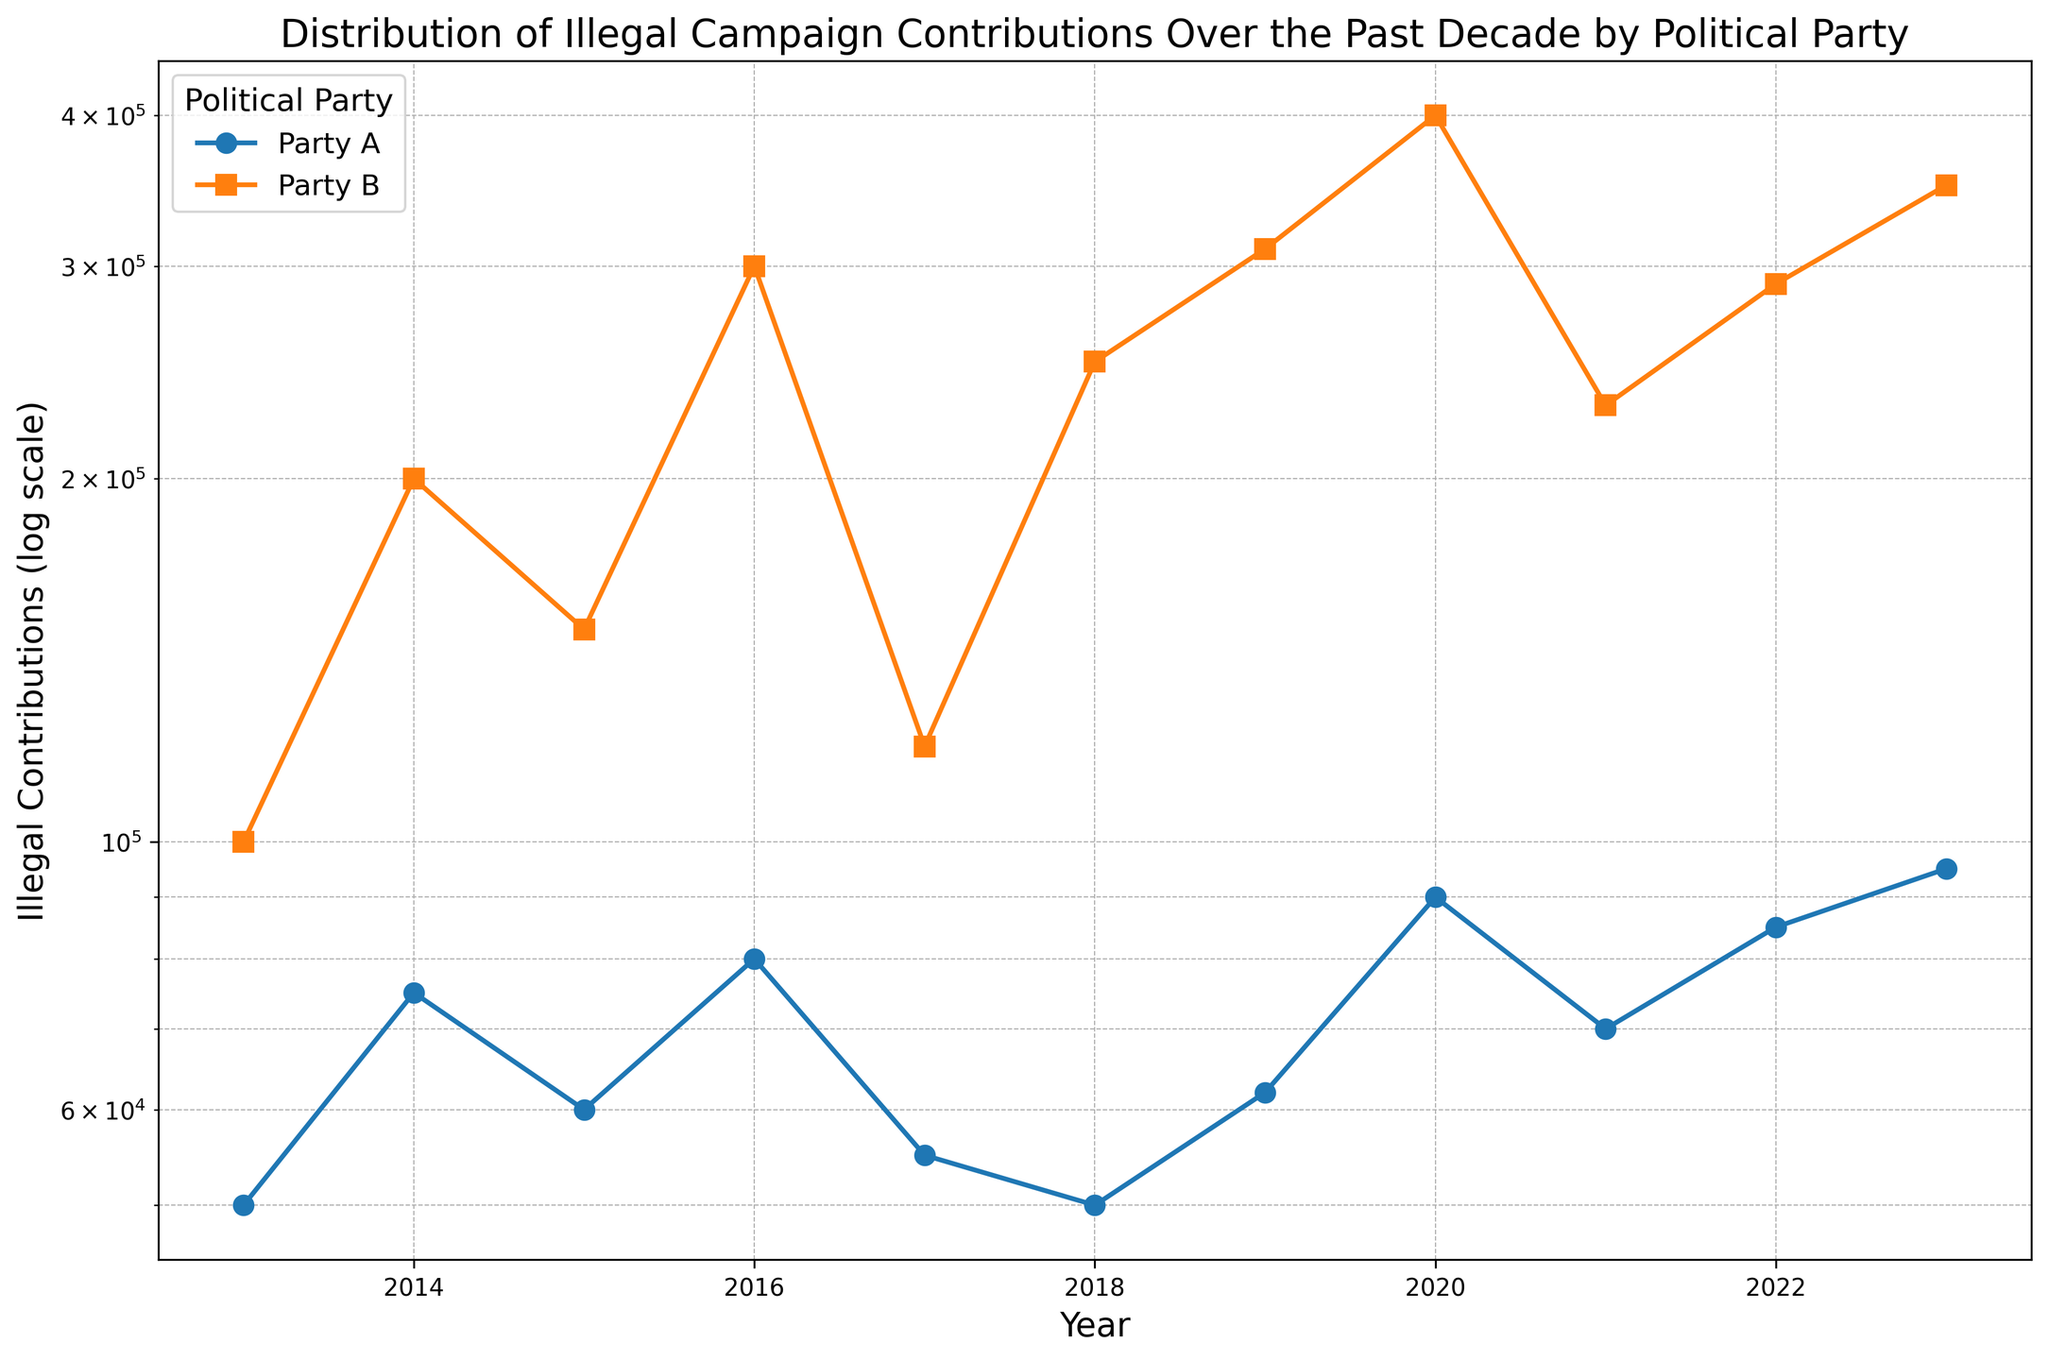Which party received the highest illegal contributions overall? To find the party with the highest illegal contributions overall, compare the contributions for each party over each year. Party B consistently has higher contributions than Party A in every year.
Answer: Party B During which year did Party A receive the most illegal contributions? Look at the data points for Party A across all years. The highest point for Party A occurs in 2023 with 95,000 illegal contributions.
Answer: 2023 Compare the illegal contributions of Party A and Party B in 2020. Which party received more, and by how much? In 2020, Party A received 90,000 illegal contributions, while Party B received 400,000. The difference is 400,000 - 90,000 = 310,000. Party B received 310,000 more illegal contributions.
Answer: Party B, 310,000 What is the overall trend in illegal contributions for Party A over the decade? Observe the line trend for Party A. It fluctuates yearly but generally shows a slight increasing trend from 50,000 in 2013 to 95,000 in 2023.
Answer: Increasing trend How many times did Party B receive illegal contributions greater than 300,000 in a year? Check yearly contributions for Party B. The amounts greater than 300,000 occur in 2019, 2020, and 2023, making it three times.
Answer: Three times In what year did Party B see the largest increase in illegal contributions compared to the previous year? Calculate the year-on-year difference for Party B. The largest increase is from 2015 (150,000) to 2016 (300,000), which is an increase of 150,000.
Answer: 2016 On average, which party had higher illegal contributions over the decade? Sum the contributions for each party over the years and divide by the number of years (10). Party A's total is 705,000, averaging 70,500/year. Party B's total is 2,700,000, averaging 270,000/year.
Answer: Party B During which years did Party B receive illegal contributions less than 150,000? Identify the years where Party B's contributions are below 150,000. This happens in 2013 (100,000), 2015 (150,000), and 2017 (120,000).
Answer: 2013, 2015, 2017 